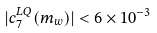<formula> <loc_0><loc_0><loc_500><loc_500>| c _ { 7 } ^ { L Q } ( m _ { w } ) | < 6 \times 1 0 ^ { - 3 }</formula> 